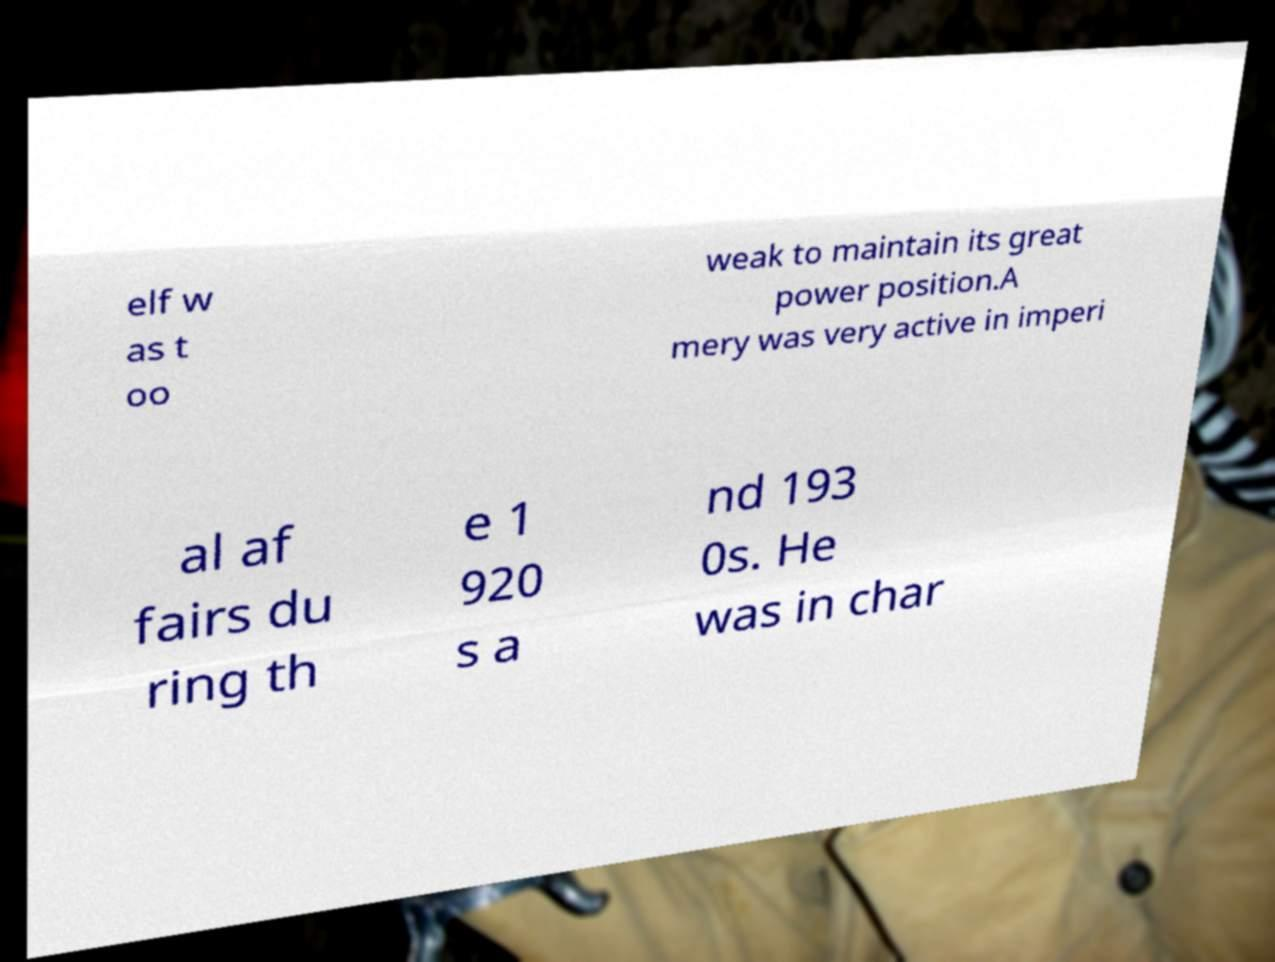Can you read and provide the text displayed in the image?This photo seems to have some interesting text. Can you extract and type it out for me? elf w as t oo weak to maintain its great power position.A mery was very active in imperi al af fairs du ring th e 1 920 s a nd 193 0s. He was in char 